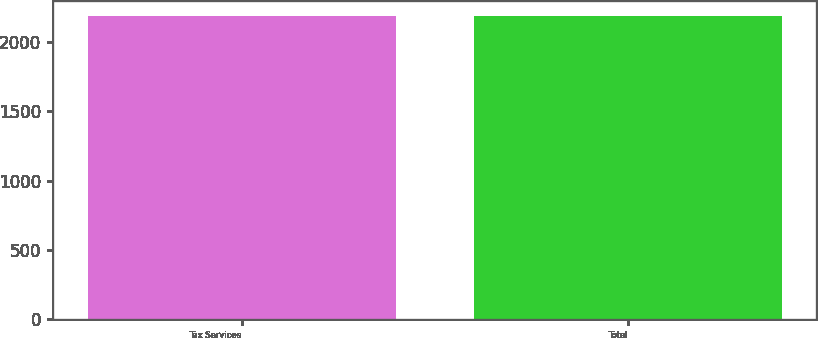Convert chart to OTSL. <chart><loc_0><loc_0><loc_500><loc_500><bar_chart><fcel>Tax Services<fcel>Total<nl><fcel>2188<fcel>2188.1<nl></chart> 